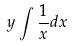Convert formula to latex. <formula><loc_0><loc_0><loc_500><loc_500>y \int \frac { 1 } { x } d x</formula> 